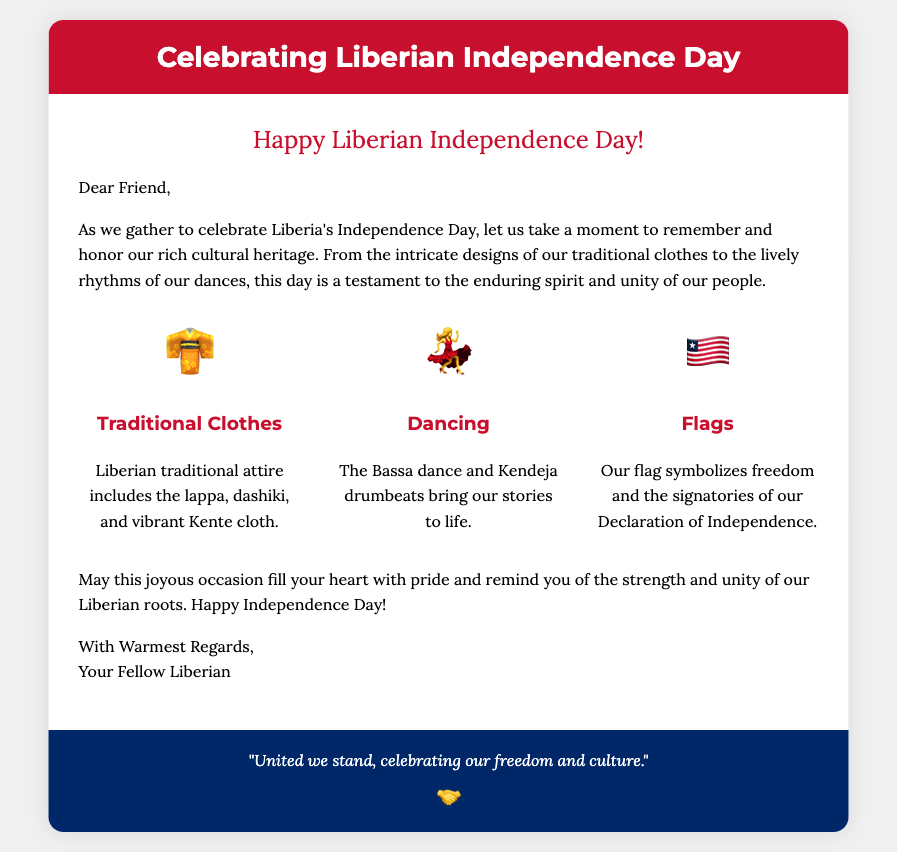What is the title of the card? The title of the card is presented in the card header section, which states "Celebrating Liberian Independence Day."
Answer: Celebrating Liberian Independence Day What is the greeting in the card? The greeting is located at the top of the card body, which reads "Happy Liberian Independence Day!"
Answer: Happy Liberian Independence Day! What are the symbols used to represent traditional clothes, dancing, and flags? The symbols are displayed as icons next to their respective categories, using 👘 for traditional clothes, 💃 for dancing, and 🇱🇷 for flags.
Answer: 👘, 💃, 🇱🇷 What is mentioned about traditional clothes in the card? The card describes traditional Liberian attire, specifically mentioning the lappa, dashiki, and vibrant Kente cloth.
Answer: Lappa, dashiki, Kente cloth Which dance is highlighted in the card? The card explicitly mentions "the Bassa dance" as part of the cultural highlights listed.
Answer: Bassa dance What is the significance of the Liberian flag according to the card? The card states that the flag symbolizes freedom and the signatories of the Declaration of Independence.
Answer: Freedom and the signatories of our Declaration of Independence What is the footer quote in the card? The footer quote summarizes the essence of unity and celebration, which is displayed at the bottom of the card.
Answer: "United we stand, celebrating our freedom and culture." How many cultural highlights are mentioned in the card? Three cultural highlights are distinctly listed in the card, representing the traditional clothes, dancing, and flags.
Answer: Three Who is the card addressed to? The card's greeting starts with "Dear Friend," indicating it is addressed to a friend.
Answer: Friend 